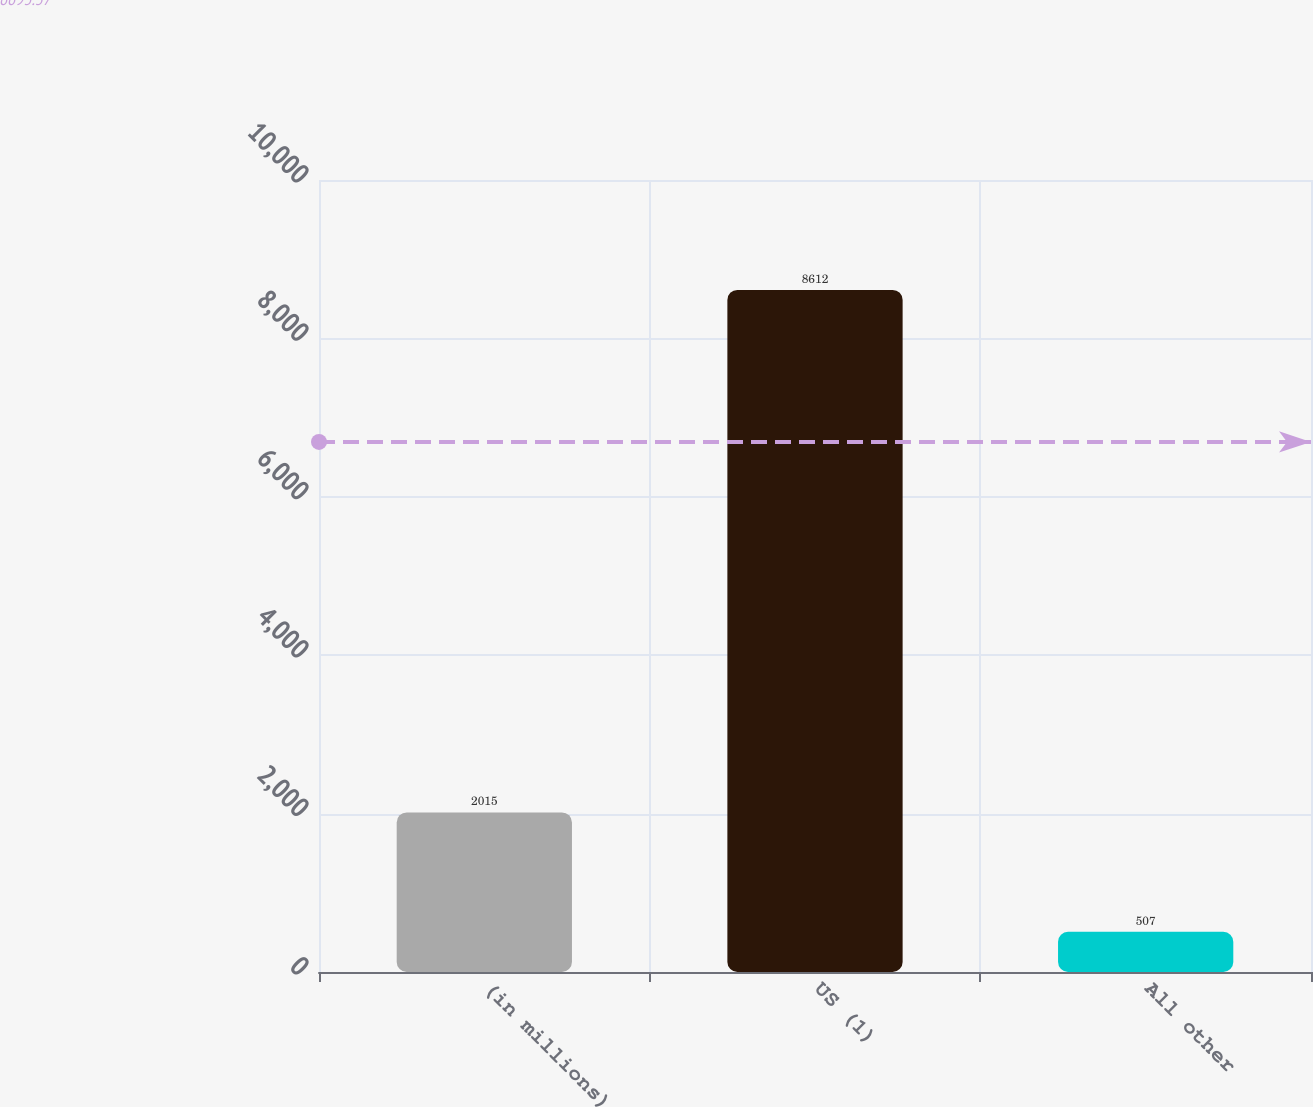Convert chart to OTSL. <chart><loc_0><loc_0><loc_500><loc_500><bar_chart><fcel>(in millions)<fcel>US (1)<fcel>All other<nl><fcel>2015<fcel>8612<fcel>507<nl></chart> 